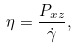Convert formula to latex. <formula><loc_0><loc_0><loc_500><loc_500>\eta = \frac { P _ { x z } } { \dot { \gamma } } ,</formula> 